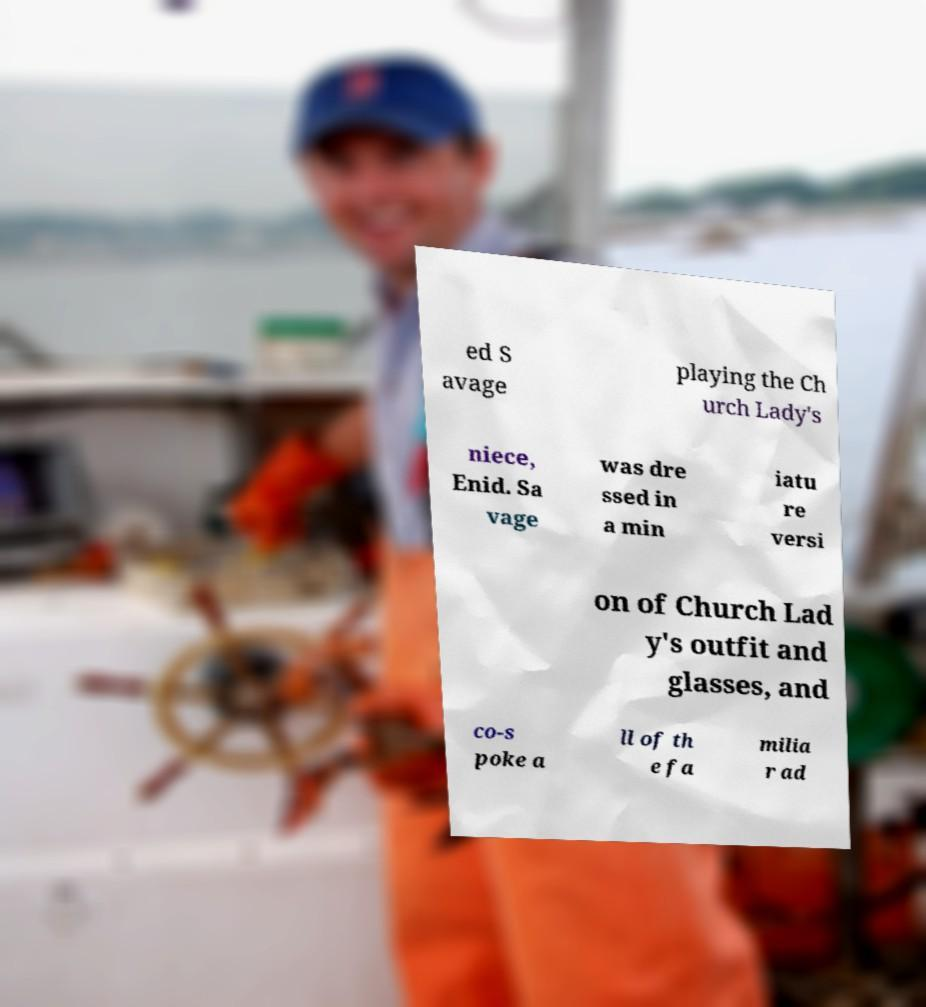Please read and relay the text visible in this image. What does it say? ed S avage playing the Ch urch Lady's niece, Enid. Sa vage was dre ssed in a min iatu re versi on of Church Lad y's outfit and glasses, and co-s poke a ll of th e fa milia r ad 